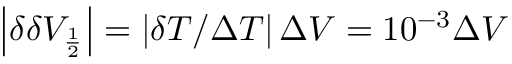<formula> <loc_0><loc_0><loc_500><loc_500>\left | \delta \delta V _ { \frac { 1 } { 2 } } \right | = \left | \delta T / \Delta T \right | \Delta V = 1 0 ^ { - 3 } \Delta V</formula> 